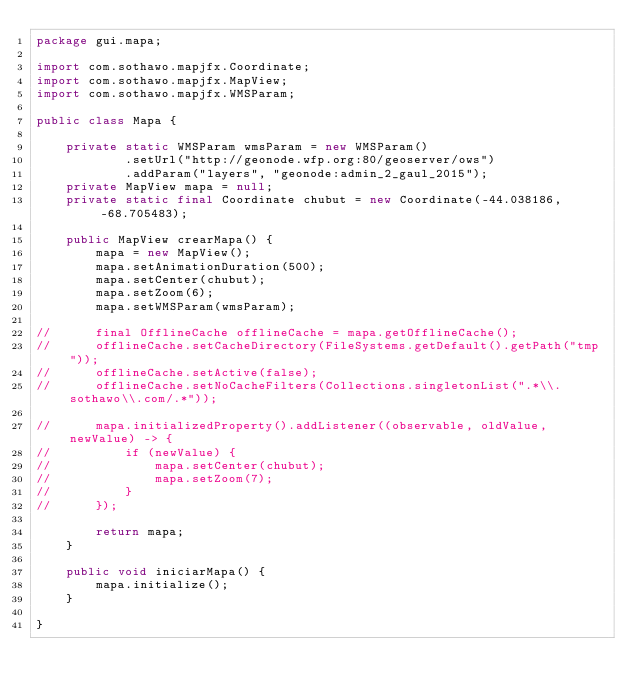<code> <loc_0><loc_0><loc_500><loc_500><_Java_>package gui.mapa;

import com.sothawo.mapjfx.Coordinate;
import com.sothawo.mapjfx.MapView;
import com.sothawo.mapjfx.WMSParam;

public class Mapa {

	private static WMSParam wmsParam = new WMSParam()
			.setUrl("http://geonode.wfp.org:80/geoserver/ows")
			.addParam("layers", "geonode:admin_2_gaul_2015");
	private MapView mapa = null;
	private static final Coordinate chubut = new Coordinate(-44.038186, -68.705483);
	
	public MapView crearMapa() {
		mapa = new MapView();
		mapa.setAnimationDuration(500);
		mapa.setCenter(chubut);
		mapa.setZoom(6);
		mapa.setWMSParam(wmsParam);
		
//		final OfflineCache offlineCache = mapa.getOfflineCache();
//		offlineCache.setCacheDirectory(FileSystems.getDefault().getPath("tmp"));
//		offlineCache.setActive(false);
//		offlineCache.setNoCacheFilters(Collections.singletonList(".*\\.sothawo\\.com/.*"));
		
//		mapa.initializedProperty().addListener((observable, oldValue, newValue) -> {
//			if (newValue) {
//				mapa.setCenter(chubut);
//				mapa.setZoom(7);
//			}
//		});
		
		return mapa;
	}
	
	public void iniciarMapa() {
		mapa.initialize();		
	}

}
</code> 